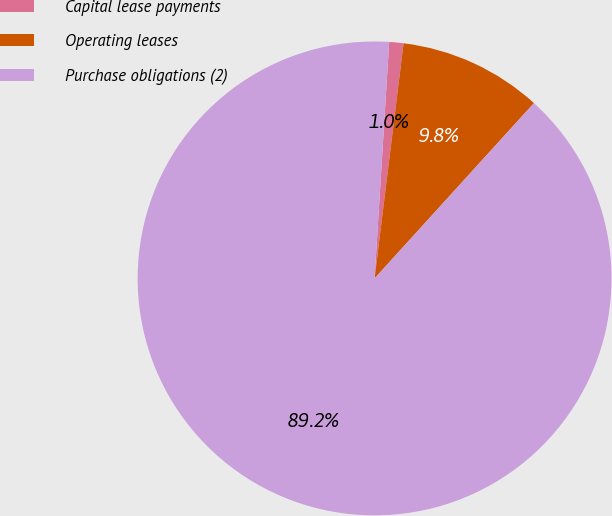Convert chart to OTSL. <chart><loc_0><loc_0><loc_500><loc_500><pie_chart><fcel>Capital lease payments<fcel>Operating leases<fcel>Purchase obligations (2)<nl><fcel>0.97%<fcel>9.79%<fcel>89.24%<nl></chart> 